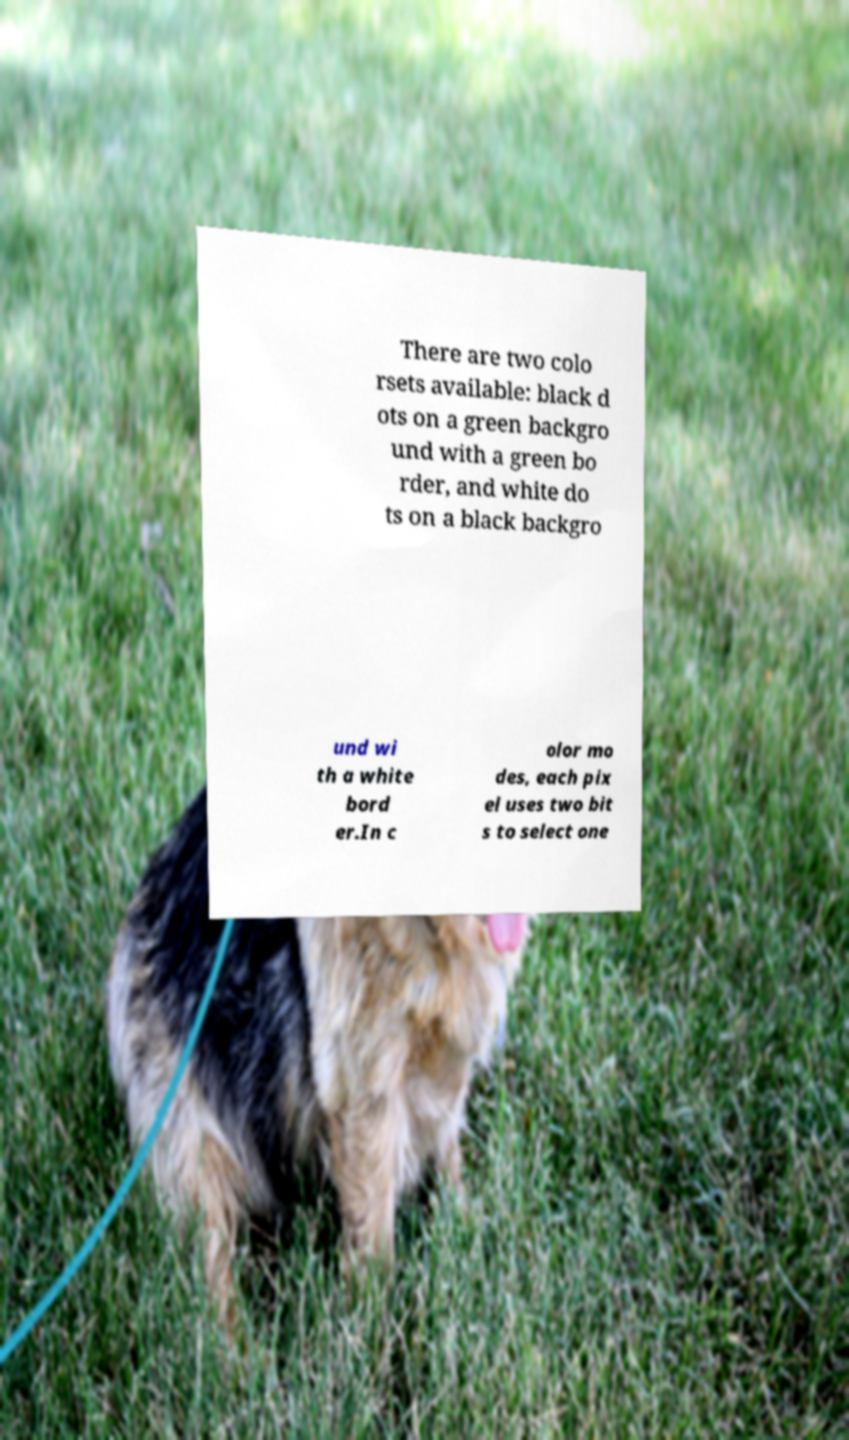Could you assist in decoding the text presented in this image and type it out clearly? There are two colo rsets available: black d ots on a green backgro und with a green bo rder, and white do ts on a black backgro und wi th a white bord er.In c olor mo des, each pix el uses two bit s to select one 